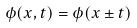Convert formula to latex. <formula><loc_0><loc_0><loc_500><loc_500>\phi ( x , t ) = \phi ( x \pm t )</formula> 